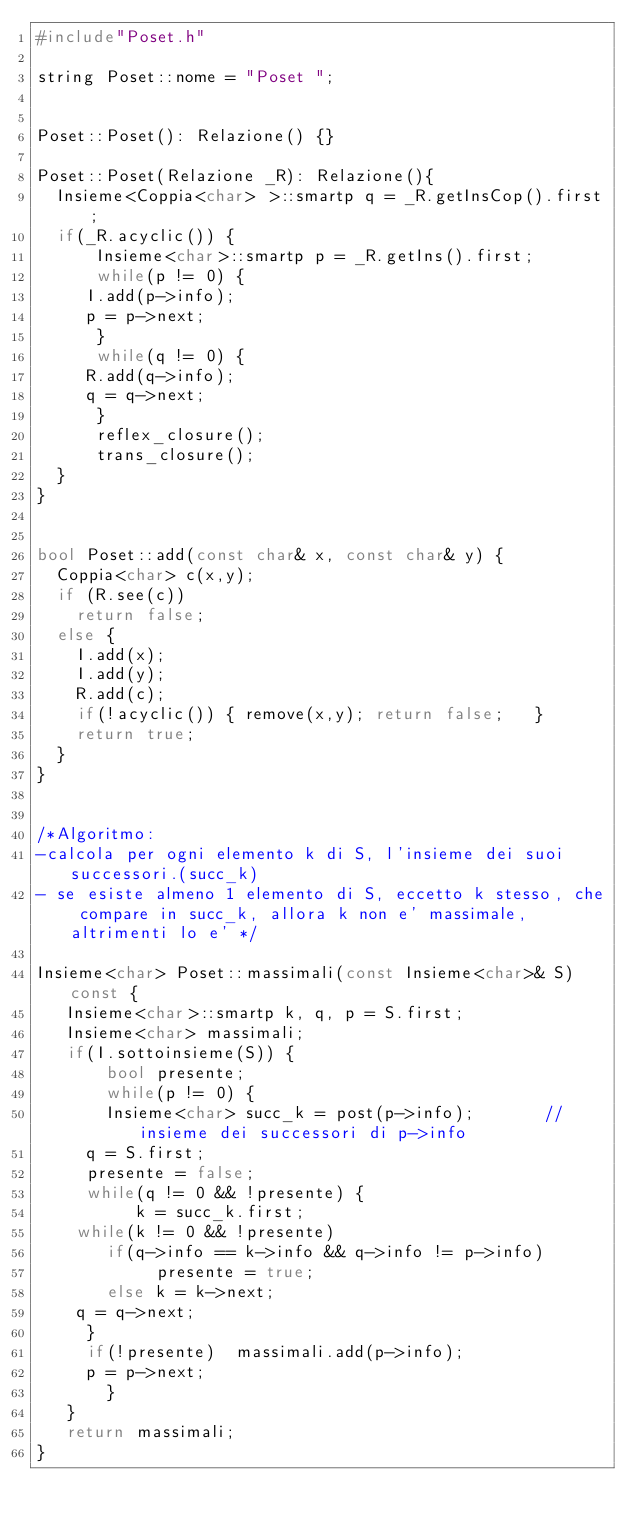Convert code to text. <code><loc_0><loc_0><loc_500><loc_500><_C++_>#include"Poset.h"

string Poset::nome = "Poset ";


Poset::Poset(): Relazione() {}

Poset::Poset(Relazione _R): Relazione(){
  Insieme<Coppia<char> >::smartp q = _R.getInsCop().first;
  if(_R.acyclic()) {
      Insieme<char>::smartp p = _R.getIns().first;
      while(p != 0) {
	   I.add(p->info);
	   p = p->next;
      }
      while(q != 0) {
	   R.add(q->info);
	   q = q->next;
      }
      reflex_closure();   
      trans_closure();
  }
}


bool Poset::add(const char& x, const char& y) {
  Coppia<char> c(x,y);
  if (R.see(c))
    return false;
  else {
    I.add(x);
    I.add(y);
    R.add(c);
    if(!acyclic()) { remove(x,y); return false;   }
    return true;
  }
}


/*Algoritmo:
-calcola per ogni elemento k di S, l'insieme dei suoi successori.(succ_k)
- se esiste almeno 1 elemento di S, eccetto k stesso, che compare in succ_k, allora k non e' massimale, altrimenti lo e' */

Insieme<char> Poset::massimali(const Insieme<char>& S) const {
   Insieme<char>::smartp k, q, p = S.first;
   Insieme<char> massimali;
   if(I.sottoinsieme(S)) {
       bool presente;
       while(p != 0) {
  	   Insieme<char> succ_k = post(p->info);       //insieme dei successori di p->info
	   q = S.first;
	   presente = false;
	   while(q != 0 && !presente) {
	        k = succ_k.first;
		while(k != 0 && !presente) 
		   if(q->info == k->info && q->info != p->info)
		        presente = true;
		   else k = k->next;
		q = q->next; 
	   }
	   if(!presente)  massimali.add(p->info);
	   p = p->next;
       }
   }
   return massimali;
}
</code> 